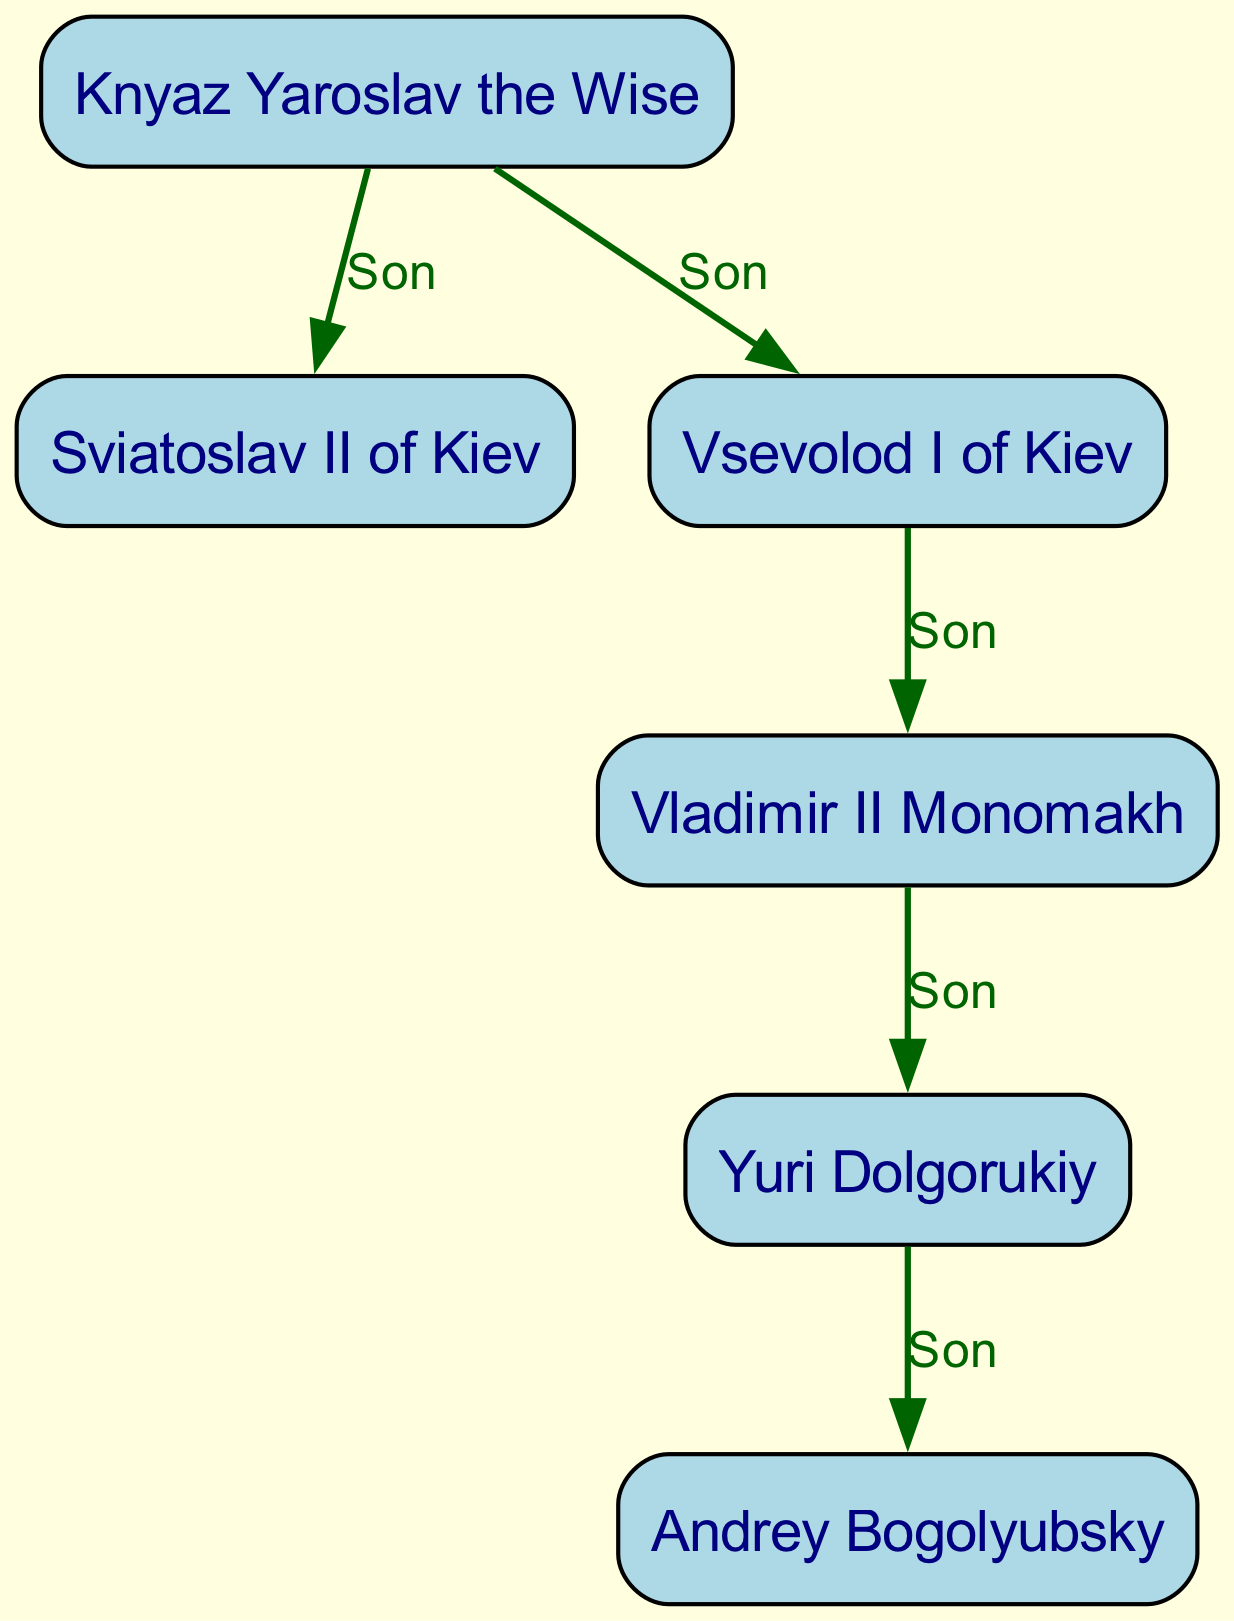What is the top node in the genealogical tree? The top node represents Knyaz Yaroslav the Wise, indicating he is the earliest ancestor in this genealogy.
Answer: Knyaz Yaroslav the Wise How many nodes are present in the diagram? Counting all the entries in the nodes section, there are six individual figures represented.
Answer: 6 What is the relationship between Knyaz Yaroslav the Wise and Sviatoslav II of Kiev? The directed edge from node 1 to node 2 labeled "Son" denotes that Knyaz Yaroslav the Wise is the father of Sviatoslav II of Kiev.
Answer: Son Which node is the child of Vsevolod I of Kiev? The arrow from node 3 to node 4 shows that Vladimir II Monomakh is the son of Vsevolod I of Kiev, identifying him as the direct offspring.
Answer: Vladimir II Monomakh How many edges are present in the diagram? Analyzing the edges provided, there are five connections illustrating the parent-child relationships between the nodes.
Answer: 5 What is the last generation in this genealogical tree? The last individual to appear within the tree, who has no descendants in this representation, is Andrey Bogolyubsky at the bottom of the chart.
Answer: Andrey Bogolyubsky Which node has two children? Observing the edges, Vsevolod I of Kiev (node 3) has an outgoing connection to Vladimir II Monomakh (node 4), indicating he has children; however, in a direct sense, Yuri Dolgorukiy (node 5) is the only node with a single child. Thus, this node has two children through succession.
Answer: Vsevolod I of Kiev What is the direct relationship between Yuri Dolgorukiy and Andrey Bogolyubsky? The arrow from node 5 to node 6 indicates that Yuri Dolgorukiy is the father of Andrey Bogolyubsky, establishing the direct connection.
Answer: Son 